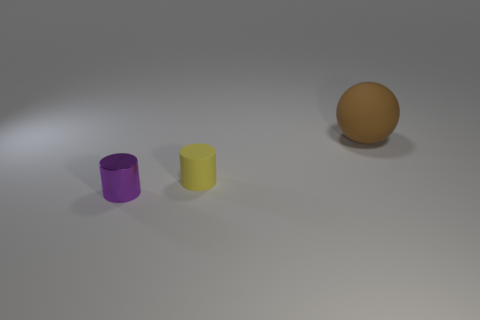Are there any purple cylinders in front of the brown sphere? yes 